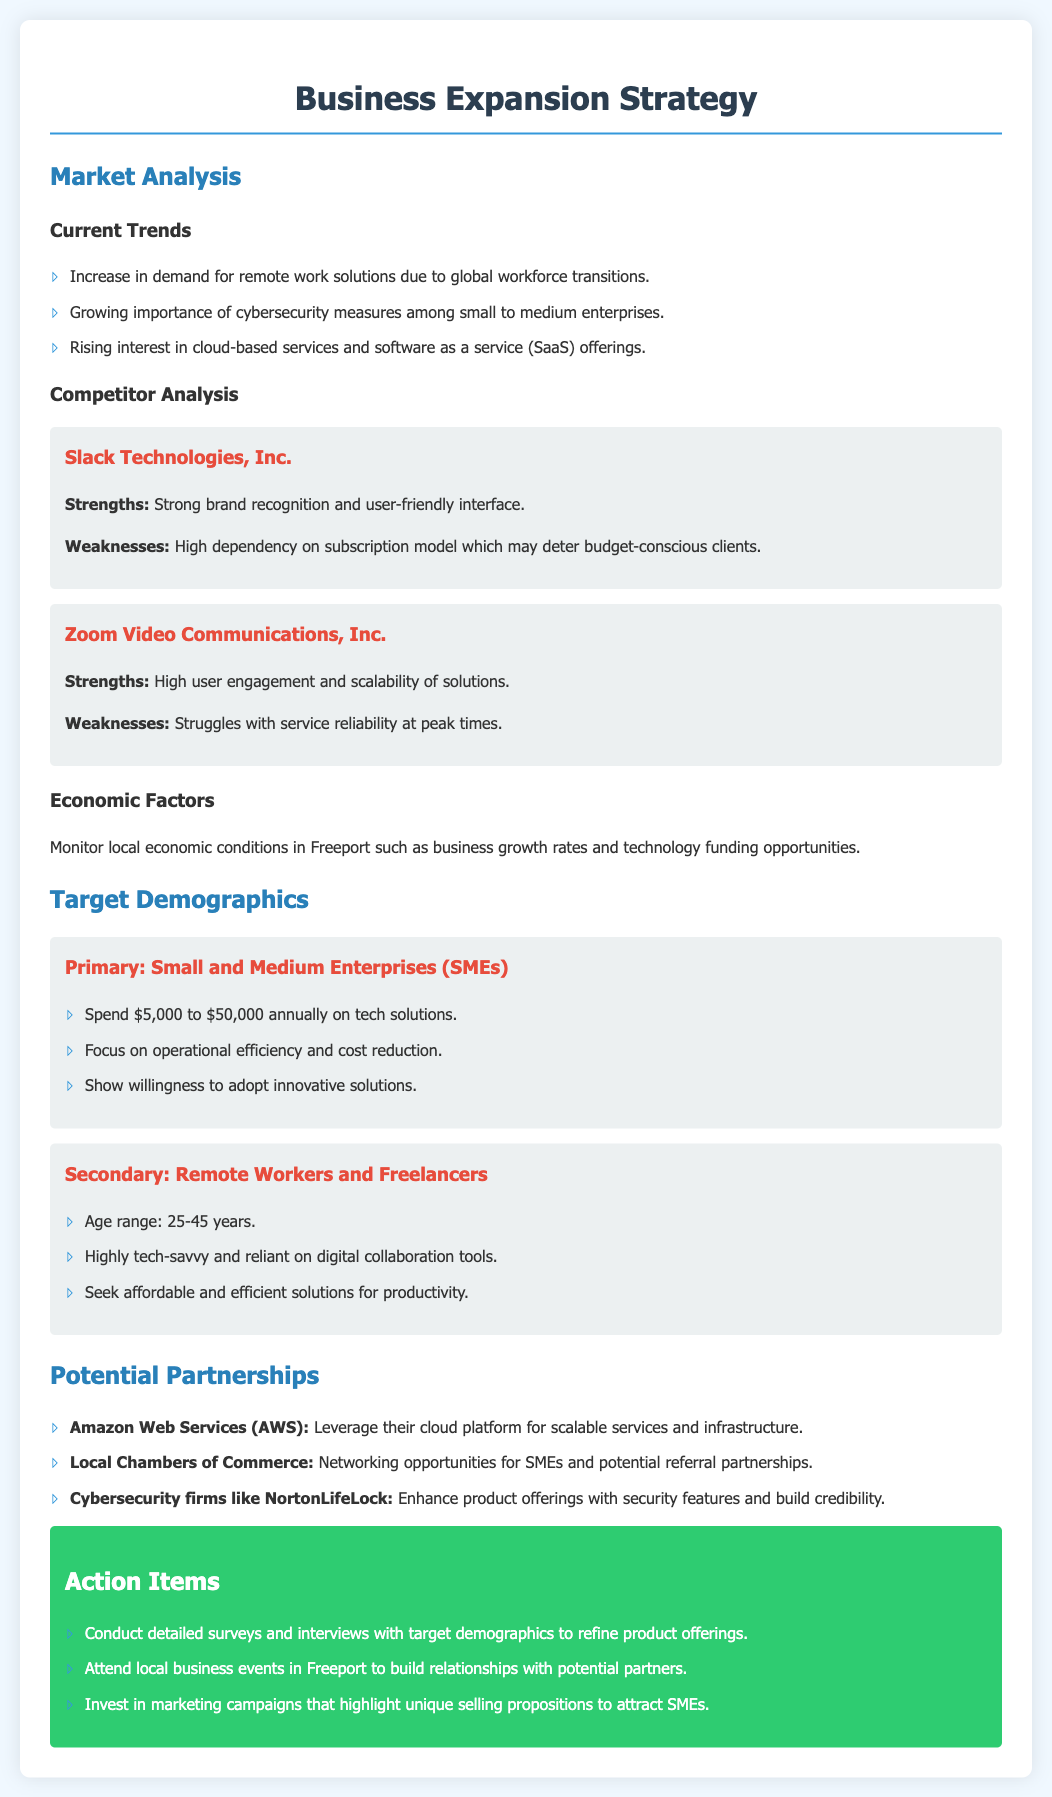What are the current trends in market analysis? The document lists three current trends in market analysis, including the demand for remote work solutions, the importance of cybersecurity, and interest in cloud-based services.
Answer: Remote work solutions, cybersecurity measures, cloud-based services Who is a competitor mentioned in the document? The document mentions Slack Technologies, Inc. as one of the competitors.
Answer: Slack Technologies, Inc What is the age range of the secondary target demographic? The document specifies an age range of 25-45 years for remote workers and freelancers.
Answer: 25-45 years What is a strength of Zoom Video Communications, Inc.? The strength noted for Zoom is its high user engagement and scalability of solutions.
Answer: High user engagement Which cloud platform is suggested for potential partnership? The document recommends Amazon Web Services (AWS) for leveraging scalable services and infrastructure.
Answer: Amazon Web Services (AWS) How much do small and medium enterprises spend annually on tech solutions? The document indicates that SMEs spend between $5,000 to $50,000 annually on tech solutions.
Answer: $5,000 to $50,000 What is one of the action items listed in the document? One action item mentioned is to conduct detailed surveys and interviews with target demographics.
Answer: Conduct detailed surveys 